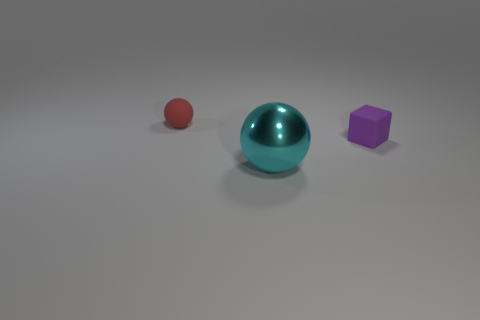Can you give me a story that connects all three objects? Certainly! Once upon a time, in a minimalist world, there existed three objects, each with its own character. The large cyan sphere was the wise elder, seasoned and smooth, its shiny surface reflecting years of experience. The small red sphere, vibrant and energetic, was the young apprentice eager to learn. And the purple cube, with its unique shape, was the thinker, always questioning the roundness of its peers. Together, they embarked on philosophical adventures, exploring concepts of shape, color, and material in their monochrome realm. 